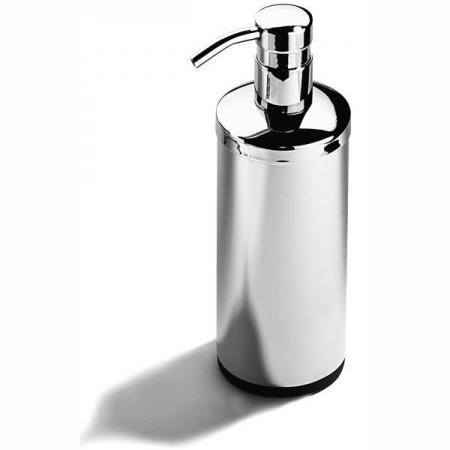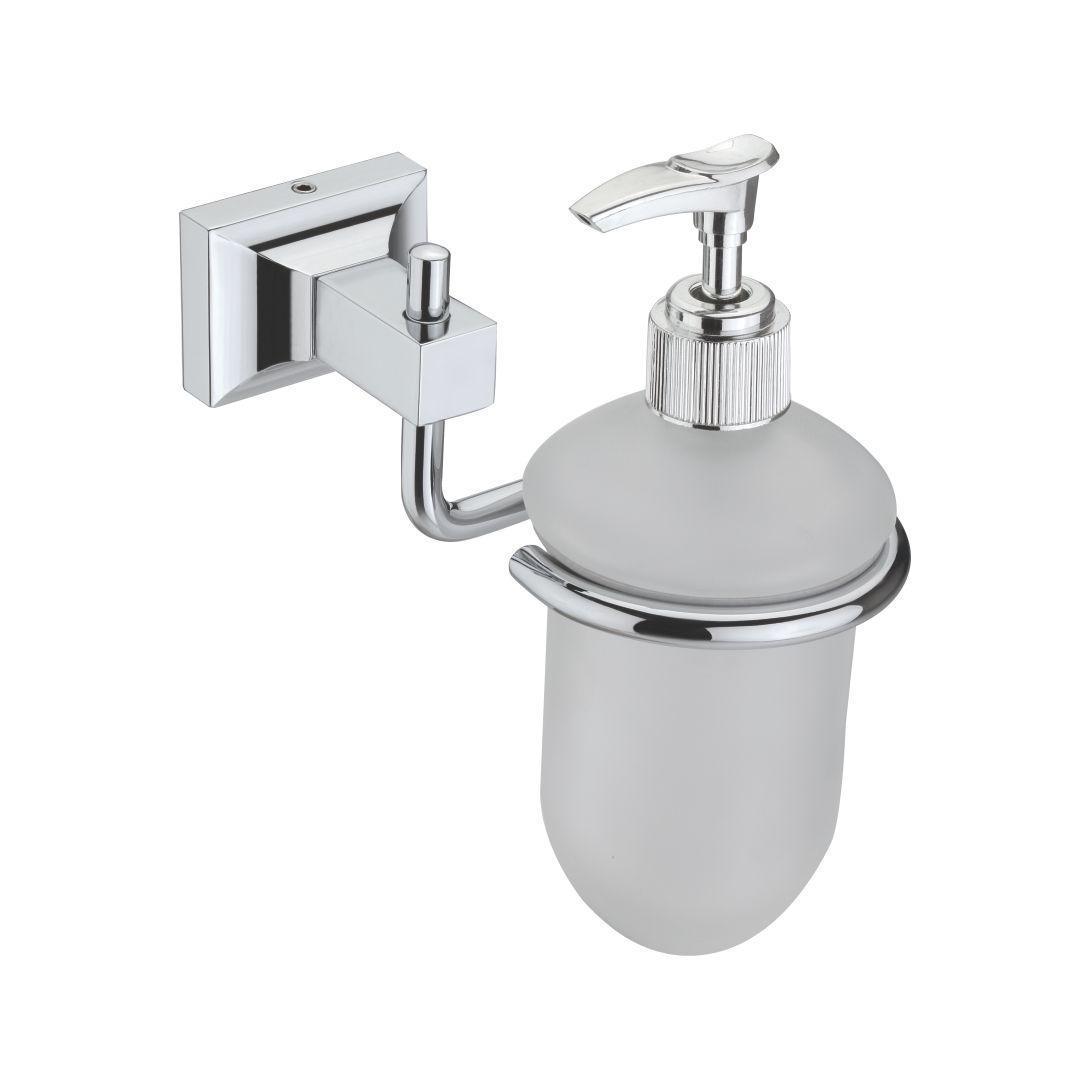The first image is the image on the left, the second image is the image on the right. For the images shown, is this caption "One soap dispenser has a flat bottom and can be set on a counter." true? Answer yes or no. Yes. 